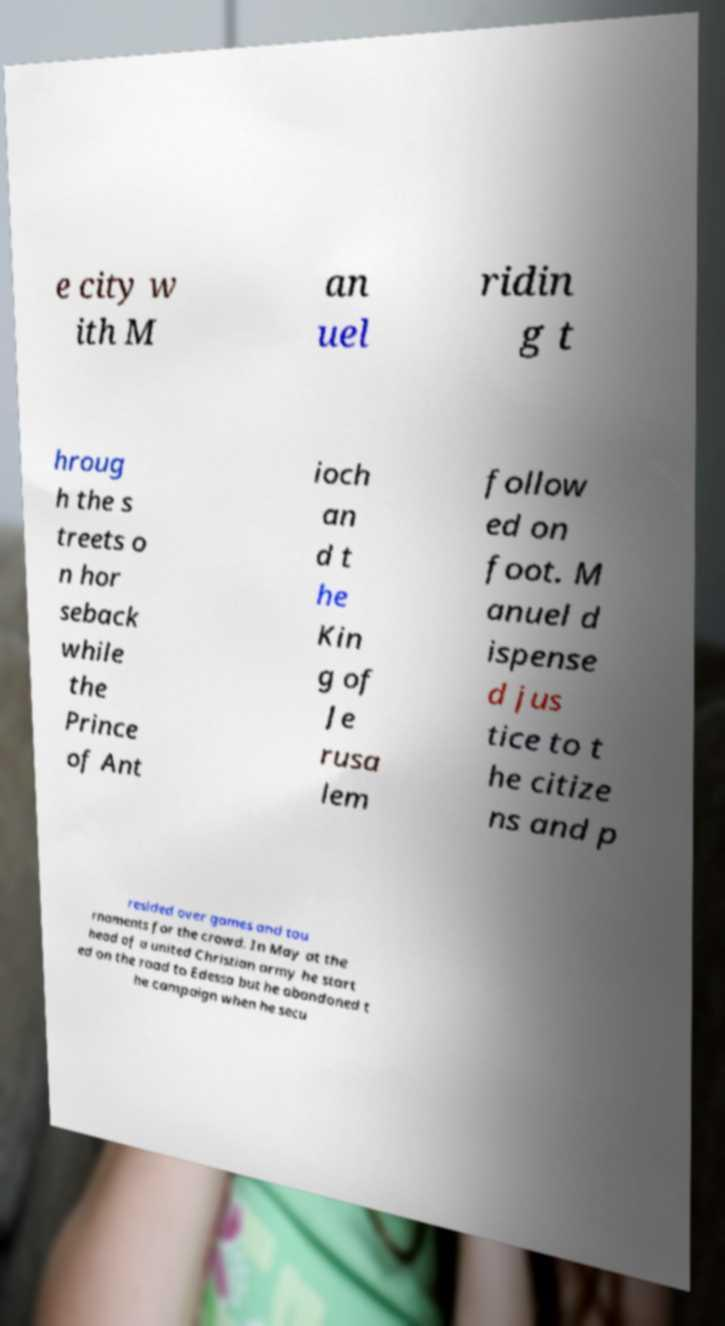Please read and relay the text visible in this image. What does it say? e city w ith M an uel ridin g t hroug h the s treets o n hor seback while the Prince of Ant ioch an d t he Kin g of Je rusa lem follow ed on foot. M anuel d ispense d jus tice to t he citize ns and p resided over games and tou rnaments for the crowd. In May at the head of a united Christian army he start ed on the road to Edessa but he abandoned t he campaign when he secu 